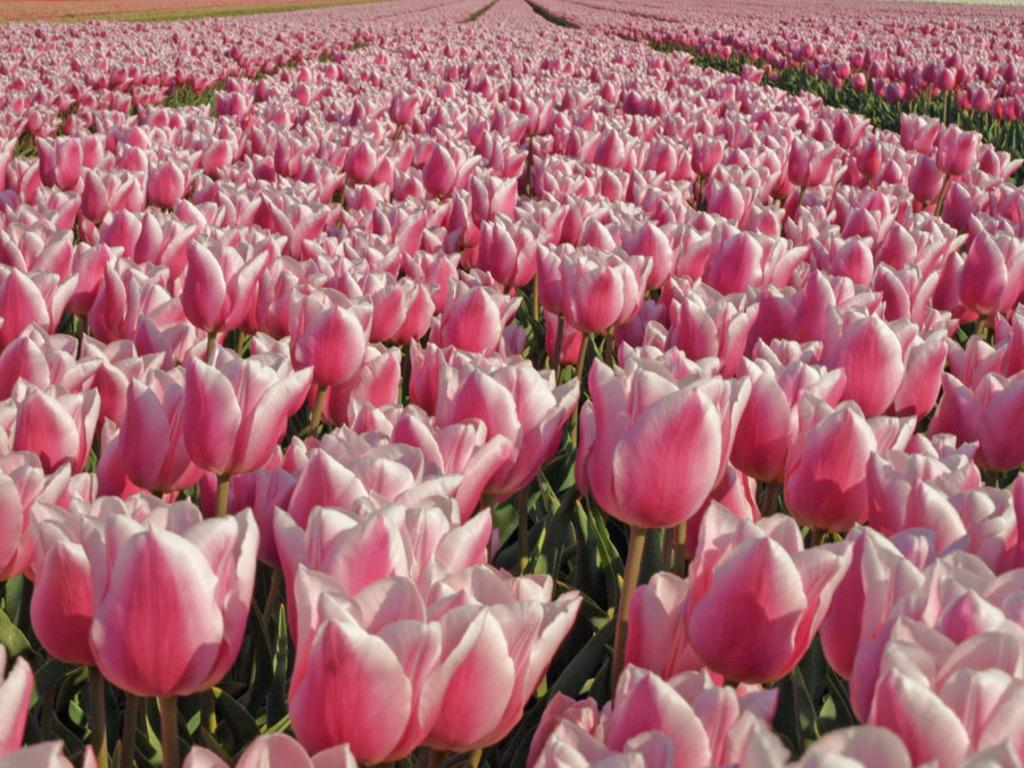What type of flora is present in the image? There are flowers in the image. What colors can be seen on the flowers? The flowers are pink and white in color. What other parts of the flowers are visible besides the petals? The flowers have leaves. What word does the woman say when the flowers burst in the image? There is no woman or bursting flowers present in the image, so this question cannot be answered. 